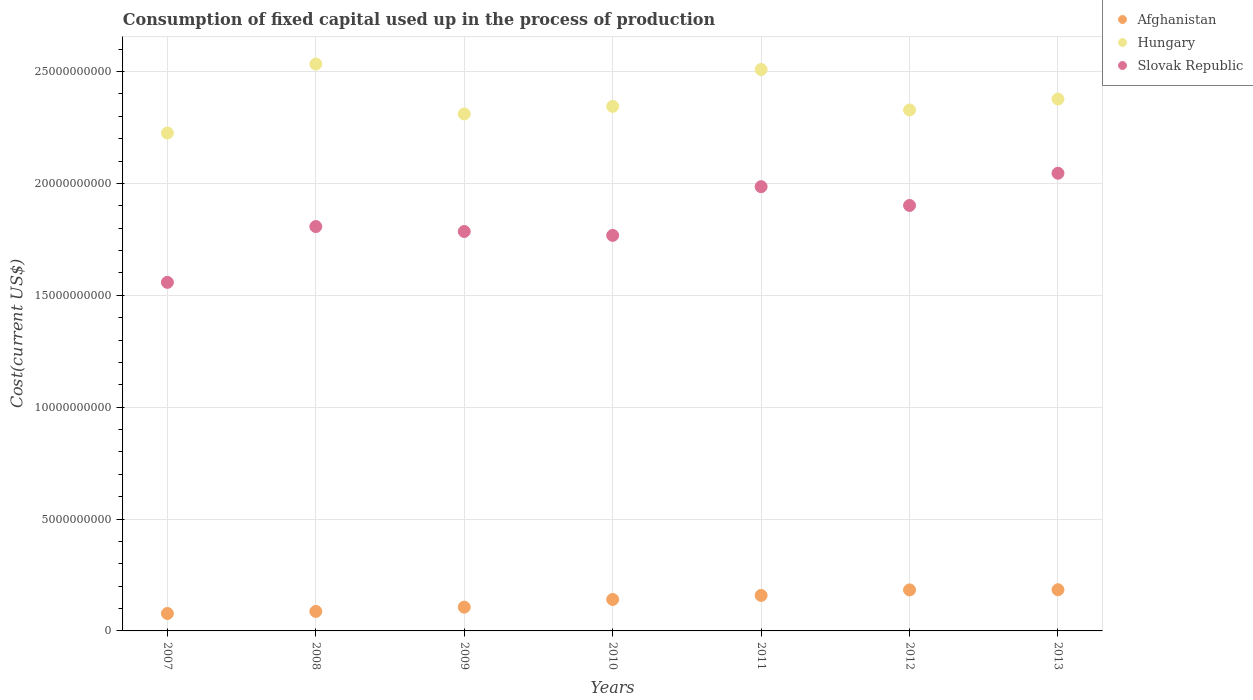How many different coloured dotlines are there?
Keep it short and to the point. 3. Is the number of dotlines equal to the number of legend labels?
Your response must be concise. Yes. What is the amount consumed in the process of production in Afghanistan in 2013?
Offer a very short reply. 1.84e+09. Across all years, what is the maximum amount consumed in the process of production in Hungary?
Offer a terse response. 2.53e+1. Across all years, what is the minimum amount consumed in the process of production in Afghanistan?
Your response must be concise. 7.79e+08. What is the total amount consumed in the process of production in Slovak Republic in the graph?
Keep it short and to the point. 1.29e+11. What is the difference between the amount consumed in the process of production in Afghanistan in 2008 and that in 2011?
Keep it short and to the point. -7.15e+08. What is the difference between the amount consumed in the process of production in Hungary in 2007 and the amount consumed in the process of production in Slovak Republic in 2010?
Provide a succinct answer. 4.58e+09. What is the average amount consumed in the process of production in Slovak Republic per year?
Your answer should be compact. 1.84e+1. In the year 2009, what is the difference between the amount consumed in the process of production in Slovak Republic and amount consumed in the process of production in Hungary?
Your answer should be very brief. -5.25e+09. In how many years, is the amount consumed in the process of production in Hungary greater than 2000000000 US$?
Ensure brevity in your answer.  7. What is the ratio of the amount consumed in the process of production in Slovak Republic in 2010 to that in 2012?
Provide a short and direct response. 0.93. Is the amount consumed in the process of production in Afghanistan in 2011 less than that in 2012?
Keep it short and to the point. Yes. What is the difference between the highest and the second highest amount consumed in the process of production in Slovak Republic?
Make the answer very short. 6.01e+08. What is the difference between the highest and the lowest amount consumed in the process of production in Slovak Republic?
Keep it short and to the point. 4.88e+09. Is the sum of the amount consumed in the process of production in Slovak Republic in 2011 and 2012 greater than the maximum amount consumed in the process of production in Hungary across all years?
Provide a succinct answer. Yes. Does the amount consumed in the process of production in Hungary monotonically increase over the years?
Keep it short and to the point. No. Is the amount consumed in the process of production in Afghanistan strictly greater than the amount consumed in the process of production in Slovak Republic over the years?
Ensure brevity in your answer.  No. Is the amount consumed in the process of production in Afghanistan strictly less than the amount consumed in the process of production in Slovak Republic over the years?
Offer a very short reply. Yes. How many dotlines are there?
Your answer should be compact. 3. How many years are there in the graph?
Offer a terse response. 7. What is the difference between two consecutive major ticks on the Y-axis?
Ensure brevity in your answer.  5.00e+09. Are the values on the major ticks of Y-axis written in scientific E-notation?
Offer a terse response. No. Does the graph contain any zero values?
Your answer should be very brief. No. Does the graph contain grids?
Your answer should be very brief. Yes. Where does the legend appear in the graph?
Keep it short and to the point. Top right. How many legend labels are there?
Provide a short and direct response. 3. How are the legend labels stacked?
Make the answer very short. Vertical. What is the title of the graph?
Make the answer very short. Consumption of fixed capital used up in the process of production. Does "Angola" appear as one of the legend labels in the graph?
Give a very brief answer. No. What is the label or title of the Y-axis?
Give a very brief answer. Cost(current US$). What is the Cost(current US$) of Afghanistan in 2007?
Provide a short and direct response. 7.79e+08. What is the Cost(current US$) of Hungary in 2007?
Offer a very short reply. 2.23e+1. What is the Cost(current US$) of Slovak Republic in 2007?
Offer a very short reply. 1.56e+1. What is the Cost(current US$) in Afghanistan in 2008?
Offer a very short reply. 8.72e+08. What is the Cost(current US$) in Hungary in 2008?
Make the answer very short. 2.53e+1. What is the Cost(current US$) in Slovak Republic in 2008?
Your answer should be compact. 1.81e+1. What is the Cost(current US$) of Afghanistan in 2009?
Keep it short and to the point. 1.06e+09. What is the Cost(current US$) of Hungary in 2009?
Your response must be concise. 2.31e+1. What is the Cost(current US$) in Slovak Republic in 2009?
Your answer should be very brief. 1.79e+1. What is the Cost(current US$) in Afghanistan in 2010?
Offer a terse response. 1.41e+09. What is the Cost(current US$) of Hungary in 2010?
Ensure brevity in your answer.  2.34e+1. What is the Cost(current US$) of Slovak Republic in 2010?
Ensure brevity in your answer.  1.77e+1. What is the Cost(current US$) of Afghanistan in 2011?
Offer a very short reply. 1.59e+09. What is the Cost(current US$) in Hungary in 2011?
Ensure brevity in your answer.  2.51e+1. What is the Cost(current US$) of Slovak Republic in 2011?
Give a very brief answer. 1.99e+1. What is the Cost(current US$) in Afghanistan in 2012?
Ensure brevity in your answer.  1.83e+09. What is the Cost(current US$) of Hungary in 2012?
Make the answer very short. 2.33e+1. What is the Cost(current US$) in Slovak Republic in 2012?
Make the answer very short. 1.90e+1. What is the Cost(current US$) of Afghanistan in 2013?
Offer a very short reply. 1.84e+09. What is the Cost(current US$) of Hungary in 2013?
Offer a very short reply. 2.38e+1. What is the Cost(current US$) in Slovak Republic in 2013?
Give a very brief answer. 2.05e+1. Across all years, what is the maximum Cost(current US$) of Afghanistan?
Keep it short and to the point. 1.84e+09. Across all years, what is the maximum Cost(current US$) in Hungary?
Provide a succinct answer. 2.53e+1. Across all years, what is the maximum Cost(current US$) in Slovak Republic?
Your answer should be very brief. 2.05e+1. Across all years, what is the minimum Cost(current US$) in Afghanistan?
Your response must be concise. 7.79e+08. Across all years, what is the minimum Cost(current US$) of Hungary?
Your answer should be compact. 2.23e+1. Across all years, what is the minimum Cost(current US$) in Slovak Republic?
Your response must be concise. 1.56e+1. What is the total Cost(current US$) in Afghanistan in the graph?
Give a very brief answer. 9.38e+09. What is the total Cost(current US$) of Hungary in the graph?
Provide a short and direct response. 1.66e+11. What is the total Cost(current US$) of Slovak Republic in the graph?
Give a very brief answer. 1.29e+11. What is the difference between the Cost(current US$) in Afghanistan in 2007 and that in 2008?
Provide a short and direct response. -9.27e+07. What is the difference between the Cost(current US$) in Hungary in 2007 and that in 2008?
Your response must be concise. -3.08e+09. What is the difference between the Cost(current US$) in Slovak Republic in 2007 and that in 2008?
Provide a succinct answer. -2.49e+09. What is the difference between the Cost(current US$) of Afghanistan in 2007 and that in 2009?
Your answer should be very brief. -2.84e+08. What is the difference between the Cost(current US$) of Hungary in 2007 and that in 2009?
Offer a terse response. -8.51e+08. What is the difference between the Cost(current US$) in Slovak Republic in 2007 and that in 2009?
Provide a succinct answer. -2.27e+09. What is the difference between the Cost(current US$) of Afghanistan in 2007 and that in 2010?
Offer a terse response. -6.28e+08. What is the difference between the Cost(current US$) in Hungary in 2007 and that in 2010?
Your answer should be very brief. -1.19e+09. What is the difference between the Cost(current US$) in Slovak Republic in 2007 and that in 2010?
Provide a succinct answer. -2.10e+09. What is the difference between the Cost(current US$) of Afghanistan in 2007 and that in 2011?
Make the answer very short. -8.08e+08. What is the difference between the Cost(current US$) of Hungary in 2007 and that in 2011?
Your answer should be very brief. -2.84e+09. What is the difference between the Cost(current US$) of Slovak Republic in 2007 and that in 2011?
Your answer should be very brief. -4.28e+09. What is the difference between the Cost(current US$) of Afghanistan in 2007 and that in 2012?
Your response must be concise. -1.05e+09. What is the difference between the Cost(current US$) of Hungary in 2007 and that in 2012?
Give a very brief answer. -1.03e+09. What is the difference between the Cost(current US$) of Slovak Republic in 2007 and that in 2012?
Provide a short and direct response. -3.44e+09. What is the difference between the Cost(current US$) in Afghanistan in 2007 and that in 2013?
Offer a very short reply. -1.06e+09. What is the difference between the Cost(current US$) in Hungary in 2007 and that in 2013?
Provide a succinct answer. -1.52e+09. What is the difference between the Cost(current US$) of Slovak Republic in 2007 and that in 2013?
Ensure brevity in your answer.  -4.88e+09. What is the difference between the Cost(current US$) in Afghanistan in 2008 and that in 2009?
Make the answer very short. -1.91e+08. What is the difference between the Cost(current US$) of Hungary in 2008 and that in 2009?
Give a very brief answer. 2.23e+09. What is the difference between the Cost(current US$) of Slovak Republic in 2008 and that in 2009?
Ensure brevity in your answer.  2.20e+08. What is the difference between the Cost(current US$) of Afghanistan in 2008 and that in 2010?
Give a very brief answer. -5.35e+08. What is the difference between the Cost(current US$) of Hungary in 2008 and that in 2010?
Keep it short and to the point. 1.89e+09. What is the difference between the Cost(current US$) in Slovak Republic in 2008 and that in 2010?
Your answer should be very brief. 3.95e+08. What is the difference between the Cost(current US$) in Afghanistan in 2008 and that in 2011?
Provide a short and direct response. -7.15e+08. What is the difference between the Cost(current US$) of Hungary in 2008 and that in 2011?
Your response must be concise. 2.45e+08. What is the difference between the Cost(current US$) of Slovak Republic in 2008 and that in 2011?
Ensure brevity in your answer.  -1.78e+09. What is the difference between the Cost(current US$) in Afghanistan in 2008 and that in 2012?
Give a very brief answer. -9.61e+08. What is the difference between the Cost(current US$) of Hungary in 2008 and that in 2012?
Provide a short and direct response. 2.05e+09. What is the difference between the Cost(current US$) in Slovak Republic in 2008 and that in 2012?
Your answer should be very brief. -9.43e+08. What is the difference between the Cost(current US$) in Afghanistan in 2008 and that in 2013?
Offer a very short reply. -9.69e+08. What is the difference between the Cost(current US$) in Hungary in 2008 and that in 2013?
Offer a terse response. 1.56e+09. What is the difference between the Cost(current US$) of Slovak Republic in 2008 and that in 2013?
Provide a succinct answer. -2.38e+09. What is the difference between the Cost(current US$) in Afghanistan in 2009 and that in 2010?
Provide a succinct answer. -3.43e+08. What is the difference between the Cost(current US$) of Hungary in 2009 and that in 2010?
Offer a very short reply. -3.38e+08. What is the difference between the Cost(current US$) of Slovak Republic in 2009 and that in 2010?
Provide a short and direct response. 1.75e+08. What is the difference between the Cost(current US$) of Afghanistan in 2009 and that in 2011?
Give a very brief answer. -5.24e+08. What is the difference between the Cost(current US$) of Hungary in 2009 and that in 2011?
Make the answer very short. -1.99e+09. What is the difference between the Cost(current US$) in Slovak Republic in 2009 and that in 2011?
Make the answer very short. -2.00e+09. What is the difference between the Cost(current US$) in Afghanistan in 2009 and that in 2012?
Your answer should be compact. -7.70e+08. What is the difference between the Cost(current US$) in Hungary in 2009 and that in 2012?
Ensure brevity in your answer.  -1.78e+08. What is the difference between the Cost(current US$) of Slovak Republic in 2009 and that in 2012?
Offer a very short reply. -1.16e+09. What is the difference between the Cost(current US$) of Afghanistan in 2009 and that in 2013?
Your response must be concise. -7.78e+08. What is the difference between the Cost(current US$) in Hungary in 2009 and that in 2013?
Your answer should be very brief. -6.66e+08. What is the difference between the Cost(current US$) of Slovak Republic in 2009 and that in 2013?
Ensure brevity in your answer.  -2.60e+09. What is the difference between the Cost(current US$) in Afghanistan in 2010 and that in 2011?
Offer a terse response. -1.80e+08. What is the difference between the Cost(current US$) of Hungary in 2010 and that in 2011?
Provide a succinct answer. -1.65e+09. What is the difference between the Cost(current US$) of Slovak Republic in 2010 and that in 2011?
Make the answer very short. -2.18e+09. What is the difference between the Cost(current US$) in Afghanistan in 2010 and that in 2012?
Ensure brevity in your answer.  -4.27e+08. What is the difference between the Cost(current US$) of Hungary in 2010 and that in 2012?
Keep it short and to the point. 1.59e+08. What is the difference between the Cost(current US$) in Slovak Republic in 2010 and that in 2012?
Your answer should be compact. -1.34e+09. What is the difference between the Cost(current US$) of Afghanistan in 2010 and that in 2013?
Make the answer very short. -4.34e+08. What is the difference between the Cost(current US$) of Hungary in 2010 and that in 2013?
Your answer should be very brief. -3.28e+08. What is the difference between the Cost(current US$) of Slovak Republic in 2010 and that in 2013?
Offer a terse response. -2.78e+09. What is the difference between the Cost(current US$) in Afghanistan in 2011 and that in 2012?
Offer a very short reply. -2.46e+08. What is the difference between the Cost(current US$) of Hungary in 2011 and that in 2012?
Give a very brief answer. 1.81e+09. What is the difference between the Cost(current US$) of Slovak Republic in 2011 and that in 2012?
Give a very brief answer. 8.39e+08. What is the difference between the Cost(current US$) of Afghanistan in 2011 and that in 2013?
Provide a short and direct response. -2.54e+08. What is the difference between the Cost(current US$) of Hungary in 2011 and that in 2013?
Your answer should be very brief. 1.32e+09. What is the difference between the Cost(current US$) in Slovak Republic in 2011 and that in 2013?
Provide a short and direct response. -6.01e+08. What is the difference between the Cost(current US$) of Afghanistan in 2012 and that in 2013?
Provide a short and direct response. -7.81e+06. What is the difference between the Cost(current US$) in Hungary in 2012 and that in 2013?
Offer a terse response. -4.88e+08. What is the difference between the Cost(current US$) of Slovak Republic in 2012 and that in 2013?
Your answer should be very brief. -1.44e+09. What is the difference between the Cost(current US$) of Afghanistan in 2007 and the Cost(current US$) of Hungary in 2008?
Your answer should be very brief. -2.46e+1. What is the difference between the Cost(current US$) of Afghanistan in 2007 and the Cost(current US$) of Slovak Republic in 2008?
Offer a terse response. -1.73e+1. What is the difference between the Cost(current US$) of Hungary in 2007 and the Cost(current US$) of Slovak Republic in 2008?
Your answer should be very brief. 4.18e+09. What is the difference between the Cost(current US$) in Afghanistan in 2007 and the Cost(current US$) in Hungary in 2009?
Provide a short and direct response. -2.23e+1. What is the difference between the Cost(current US$) of Afghanistan in 2007 and the Cost(current US$) of Slovak Republic in 2009?
Your response must be concise. -1.71e+1. What is the difference between the Cost(current US$) of Hungary in 2007 and the Cost(current US$) of Slovak Republic in 2009?
Your answer should be compact. 4.40e+09. What is the difference between the Cost(current US$) of Afghanistan in 2007 and the Cost(current US$) of Hungary in 2010?
Make the answer very short. -2.27e+1. What is the difference between the Cost(current US$) in Afghanistan in 2007 and the Cost(current US$) in Slovak Republic in 2010?
Your response must be concise. -1.69e+1. What is the difference between the Cost(current US$) of Hungary in 2007 and the Cost(current US$) of Slovak Republic in 2010?
Provide a short and direct response. 4.58e+09. What is the difference between the Cost(current US$) in Afghanistan in 2007 and the Cost(current US$) in Hungary in 2011?
Ensure brevity in your answer.  -2.43e+1. What is the difference between the Cost(current US$) in Afghanistan in 2007 and the Cost(current US$) in Slovak Republic in 2011?
Provide a succinct answer. -1.91e+1. What is the difference between the Cost(current US$) of Hungary in 2007 and the Cost(current US$) of Slovak Republic in 2011?
Your answer should be very brief. 2.40e+09. What is the difference between the Cost(current US$) of Afghanistan in 2007 and the Cost(current US$) of Hungary in 2012?
Ensure brevity in your answer.  -2.25e+1. What is the difference between the Cost(current US$) in Afghanistan in 2007 and the Cost(current US$) in Slovak Republic in 2012?
Your answer should be compact. -1.82e+1. What is the difference between the Cost(current US$) of Hungary in 2007 and the Cost(current US$) of Slovak Republic in 2012?
Offer a terse response. 3.24e+09. What is the difference between the Cost(current US$) of Afghanistan in 2007 and the Cost(current US$) of Hungary in 2013?
Keep it short and to the point. -2.30e+1. What is the difference between the Cost(current US$) of Afghanistan in 2007 and the Cost(current US$) of Slovak Republic in 2013?
Ensure brevity in your answer.  -1.97e+1. What is the difference between the Cost(current US$) in Hungary in 2007 and the Cost(current US$) in Slovak Republic in 2013?
Give a very brief answer. 1.80e+09. What is the difference between the Cost(current US$) in Afghanistan in 2008 and the Cost(current US$) in Hungary in 2009?
Your answer should be compact. -2.22e+1. What is the difference between the Cost(current US$) in Afghanistan in 2008 and the Cost(current US$) in Slovak Republic in 2009?
Make the answer very short. -1.70e+1. What is the difference between the Cost(current US$) in Hungary in 2008 and the Cost(current US$) in Slovak Republic in 2009?
Offer a terse response. 7.48e+09. What is the difference between the Cost(current US$) of Afghanistan in 2008 and the Cost(current US$) of Hungary in 2010?
Ensure brevity in your answer.  -2.26e+1. What is the difference between the Cost(current US$) in Afghanistan in 2008 and the Cost(current US$) in Slovak Republic in 2010?
Your response must be concise. -1.68e+1. What is the difference between the Cost(current US$) of Hungary in 2008 and the Cost(current US$) of Slovak Republic in 2010?
Your response must be concise. 7.66e+09. What is the difference between the Cost(current US$) in Afghanistan in 2008 and the Cost(current US$) in Hungary in 2011?
Provide a succinct answer. -2.42e+1. What is the difference between the Cost(current US$) of Afghanistan in 2008 and the Cost(current US$) of Slovak Republic in 2011?
Give a very brief answer. -1.90e+1. What is the difference between the Cost(current US$) of Hungary in 2008 and the Cost(current US$) of Slovak Republic in 2011?
Your answer should be very brief. 5.48e+09. What is the difference between the Cost(current US$) in Afghanistan in 2008 and the Cost(current US$) in Hungary in 2012?
Your answer should be compact. -2.24e+1. What is the difference between the Cost(current US$) of Afghanistan in 2008 and the Cost(current US$) of Slovak Republic in 2012?
Ensure brevity in your answer.  -1.81e+1. What is the difference between the Cost(current US$) of Hungary in 2008 and the Cost(current US$) of Slovak Republic in 2012?
Your answer should be very brief. 6.32e+09. What is the difference between the Cost(current US$) in Afghanistan in 2008 and the Cost(current US$) in Hungary in 2013?
Offer a very short reply. -2.29e+1. What is the difference between the Cost(current US$) of Afghanistan in 2008 and the Cost(current US$) of Slovak Republic in 2013?
Offer a terse response. -1.96e+1. What is the difference between the Cost(current US$) of Hungary in 2008 and the Cost(current US$) of Slovak Republic in 2013?
Your answer should be very brief. 4.88e+09. What is the difference between the Cost(current US$) of Afghanistan in 2009 and the Cost(current US$) of Hungary in 2010?
Offer a terse response. -2.24e+1. What is the difference between the Cost(current US$) of Afghanistan in 2009 and the Cost(current US$) of Slovak Republic in 2010?
Provide a succinct answer. -1.66e+1. What is the difference between the Cost(current US$) of Hungary in 2009 and the Cost(current US$) of Slovak Republic in 2010?
Offer a very short reply. 5.43e+09. What is the difference between the Cost(current US$) of Afghanistan in 2009 and the Cost(current US$) of Hungary in 2011?
Make the answer very short. -2.40e+1. What is the difference between the Cost(current US$) in Afghanistan in 2009 and the Cost(current US$) in Slovak Republic in 2011?
Provide a succinct answer. -1.88e+1. What is the difference between the Cost(current US$) in Hungary in 2009 and the Cost(current US$) in Slovak Republic in 2011?
Provide a short and direct response. 3.25e+09. What is the difference between the Cost(current US$) in Afghanistan in 2009 and the Cost(current US$) in Hungary in 2012?
Give a very brief answer. -2.22e+1. What is the difference between the Cost(current US$) of Afghanistan in 2009 and the Cost(current US$) of Slovak Republic in 2012?
Your response must be concise. -1.80e+1. What is the difference between the Cost(current US$) of Hungary in 2009 and the Cost(current US$) of Slovak Republic in 2012?
Offer a terse response. 4.09e+09. What is the difference between the Cost(current US$) in Afghanistan in 2009 and the Cost(current US$) in Hungary in 2013?
Give a very brief answer. -2.27e+1. What is the difference between the Cost(current US$) in Afghanistan in 2009 and the Cost(current US$) in Slovak Republic in 2013?
Your answer should be very brief. -1.94e+1. What is the difference between the Cost(current US$) in Hungary in 2009 and the Cost(current US$) in Slovak Republic in 2013?
Your response must be concise. 2.65e+09. What is the difference between the Cost(current US$) of Afghanistan in 2010 and the Cost(current US$) of Hungary in 2011?
Your response must be concise. -2.37e+1. What is the difference between the Cost(current US$) in Afghanistan in 2010 and the Cost(current US$) in Slovak Republic in 2011?
Provide a succinct answer. -1.84e+1. What is the difference between the Cost(current US$) of Hungary in 2010 and the Cost(current US$) of Slovak Republic in 2011?
Offer a very short reply. 3.59e+09. What is the difference between the Cost(current US$) of Afghanistan in 2010 and the Cost(current US$) of Hungary in 2012?
Give a very brief answer. -2.19e+1. What is the difference between the Cost(current US$) of Afghanistan in 2010 and the Cost(current US$) of Slovak Republic in 2012?
Provide a succinct answer. -1.76e+1. What is the difference between the Cost(current US$) in Hungary in 2010 and the Cost(current US$) in Slovak Republic in 2012?
Offer a terse response. 4.43e+09. What is the difference between the Cost(current US$) in Afghanistan in 2010 and the Cost(current US$) in Hungary in 2013?
Your answer should be compact. -2.24e+1. What is the difference between the Cost(current US$) in Afghanistan in 2010 and the Cost(current US$) in Slovak Republic in 2013?
Provide a succinct answer. -1.91e+1. What is the difference between the Cost(current US$) in Hungary in 2010 and the Cost(current US$) in Slovak Republic in 2013?
Keep it short and to the point. 2.99e+09. What is the difference between the Cost(current US$) of Afghanistan in 2011 and the Cost(current US$) of Hungary in 2012?
Offer a very short reply. -2.17e+1. What is the difference between the Cost(current US$) in Afghanistan in 2011 and the Cost(current US$) in Slovak Republic in 2012?
Ensure brevity in your answer.  -1.74e+1. What is the difference between the Cost(current US$) in Hungary in 2011 and the Cost(current US$) in Slovak Republic in 2012?
Keep it short and to the point. 6.08e+09. What is the difference between the Cost(current US$) of Afghanistan in 2011 and the Cost(current US$) of Hungary in 2013?
Offer a terse response. -2.22e+1. What is the difference between the Cost(current US$) in Afghanistan in 2011 and the Cost(current US$) in Slovak Republic in 2013?
Provide a succinct answer. -1.89e+1. What is the difference between the Cost(current US$) in Hungary in 2011 and the Cost(current US$) in Slovak Republic in 2013?
Your answer should be compact. 4.64e+09. What is the difference between the Cost(current US$) of Afghanistan in 2012 and the Cost(current US$) of Hungary in 2013?
Ensure brevity in your answer.  -2.19e+1. What is the difference between the Cost(current US$) of Afghanistan in 2012 and the Cost(current US$) of Slovak Republic in 2013?
Offer a very short reply. -1.86e+1. What is the difference between the Cost(current US$) in Hungary in 2012 and the Cost(current US$) in Slovak Republic in 2013?
Offer a very short reply. 2.83e+09. What is the average Cost(current US$) of Afghanistan per year?
Your answer should be compact. 1.34e+09. What is the average Cost(current US$) in Hungary per year?
Keep it short and to the point. 2.38e+1. What is the average Cost(current US$) of Slovak Republic per year?
Ensure brevity in your answer.  1.84e+1. In the year 2007, what is the difference between the Cost(current US$) of Afghanistan and Cost(current US$) of Hungary?
Ensure brevity in your answer.  -2.15e+1. In the year 2007, what is the difference between the Cost(current US$) of Afghanistan and Cost(current US$) of Slovak Republic?
Provide a short and direct response. -1.48e+1. In the year 2007, what is the difference between the Cost(current US$) of Hungary and Cost(current US$) of Slovak Republic?
Your response must be concise. 6.68e+09. In the year 2008, what is the difference between the Cost(current US$) in Afghanistan and Cost(current US$) in Hungary?
Provide a short and direct response. -2.45e+1. In the year 2008, what is the difference between the Cost(current US$) of Afghanistan and Cost(current US$) of Slovak Republic?
Offer a terse response. -1.72e+1. In the year 2008, what is the difference between the Cost(current US$) in Hungary and Cost(current US$) in Slovak Republic?
Your answer should be very brief. 7.26e+09. In the year 2009, what is the difference between the Cost(current US$) of Afghanistan and Cost(current US$) of Hungary?
Give a very brief answer. -2.20e+1. In the year 2009, what is the difference between the Cost(current US$) in Afghanistan and Cost(current US$) in Slovak Republic?
Provide a succinct answer. -1.68e+1. In the year 2009, what is the difference between the Cost(current US$) in Hungary and Cost(current US$) in Slovak Republic?
Your answer should be very brief. 5.25e+09. In the year 2010, what is the difference between the Cost(current US$) of Afghanistan and Cost(current US$) of Hungary?
Keep it short and to the point. -2.20e+1. In the year 2010, what is the difference between the Cost(current US$) in Afghanistan and Cost(current US$) in Slovak Republic?
Your answer should be very brief. -1.63e+1. In the year 2010, what is the difference between the Cost(current US$) in Hungary and Cost(current US$) in Slovak Republic?
Provide a short and direct response. 5.77e+09. In the year 2011, what is the difference between the Cost(current US$) in Afghanistan and Cost(current US$) in Hungary?
Your answer should be compact. -2.35e+1. In the year 2011, what is the difference between the Cost(current US$) of Afghanistan and Cost(current US$) of Slovak Republic?
Your answer should be compact. -1.83e+1. In the year 2011, what is the difference between the Cost(current US$) in Hungary and Cost(current US$) in Slovak Republic?
Offer a very short reply. 5.24e+09. In the year 2012, what is the difference between the Cost(current US$) of Afghanistan and Cost(current US$) of Hungary?
Provide a succinct answer. -2.15e+1. In the year 2012, what is the difference between the Cost(current US$) of Afghanistan and Cost(current US$) of Slovak Republic?
Your answer should be compact. -1.72e+1. In the year 2012, what is the difference between the Cost(current US$) in Hungary and Cost(current US$) in Slovak Republic?
Make the answer very short. 4.27e+09. In the year 2013, what is the difference between the Cost(current US$) of Afghanistan and Cost(current US$) of Hungary?
Make the answer very short. -2.19e+1. In the year 2013, what is the difference between the Cost(current US$) of Afghanistan and Cost(current US$) of Slovak Republic?
Ensure brevity in your answer.  -1.86e+1. In the year 2013, what is the difference between the Cost(current US$) of Hungary and Cost(current US$) of Slovak Republic?
Your answer should be very brief. 3.32e+09. What is the ratio of the Cost(current US$) of Afghanistan in 2007 to that in 2008?
Provide a short and direct response. 0.89. What is the ratio of the Cost(current US$) of Hungary in 2007 to that in 2008?
Offer a very short reply. 0.88. What is the ratio of the Cost(current US$) of Slovak Republic in 2007 to that in 2008?
Your answer should be very brief. 0.86. What is the ratio of the Cost(current US$) in Afghanistan in 2007 to that in 2009?
Your answer should be very brief. 0.73. What is the ratio of the Cost(current US$) in Hungary in 2007 to that in 2009?
Keep it short and to the point. 0.96. What is the ratio of the Cost(current US$) in Slovak Republic in 2007 to that in 2009?
Your answer should be very brief. 0.87. What is the ratio of the Cost(current US$) in Afghanistan in 2007 to that in 2010?
Ensure brevity in your answer.  0.55. What is the ratio of the Cost(current US$) in Hungary in 2007 to that in 2010?
Your answer should be very brief. 0.95. What is the ratio of the Cost(current US$) in Slovak Republic in 2007 to that in 2010?
Provide a short and direct response. 0.88. What is the ratio of the Cost(current US$) in Afghanistan in 2007 to that in 2011?
Make the answer very short. 0.49. What is the ratio of the Cost(current US$) in Hungary in 2007 to that in 2011?
Your answer should be very brief. 0.89. What is the ratio of the Cost(current US$) in Slovak Republic in 2007 to that in 2011?
Make the answer very short. 0.78. What is the ratio of the Cost(current US$) of Afghanistan in 2007 to that in 2012?
Your answer should be very brief. 0.42. What is the ratio of the Cost(current US$) of Hungary in 2007 to that in 2012?
Ensure brevity in your answer.  0.96. What is the ratio of the Cost(current US$) in Slovak Republic in 2007 to that in 2012?
Ensure brevity in your answer.  0.82. What is the ratio of the Cost(current US$) of Afghanistan in 2007 to that in 2013?
Provide a succinct answer. 0.42. What is the ratio of the Cost(current US$) of Hungary in 2007 to that in 2013?
Your answer should be very brief. 0.94. What is the ratio of the Cost(current US$) in Slovak Republic in 2007 to that in 2013?
Ensure brevity in your answer.  0.76. What is the ratio of the Cost(current US$) of Afghanistan in 2008 to that in 2009?
Give a very brief answer. 0.82. What is the ratio of the Cost(current US$) of Hungary in 2008 to that in 2009?
Offer a very short reply. 1.1. What is the ratio of the Cost(current US$) in Slovak Republic in 2008 to that in 2009?
Offer a very short reply. 1.01. What is the ratio of the Cost(current US$) of Afghanistan in 2008 to that in 2010?
Provide a short and direct response. 0.62. What is the ratio of the Cost(current US$) in Hungary in 2008 to that in 2010?
Make the answer very short. 1.08. What is the ratio of the Cost(current US$) in Slovak Republic in 2008 to that in 2010?
Provide a succinct answer. 1.02. What is the ratio of the Cost(current US$) of Afghanistan in 2008 to that in 2011?
Your response must be concise. 0.55. What is the ratio of the Cost(current US$) of Hungary in 2008 to that in 2011?
Ensure brevity in your answer.  1.01. What is the ratio of the Cost(current US$) of Slovak Republic in 2008 to that in 2011?
Offer a very short reply. 0.91. What is the ratio of the Cost(current US$) of Afghanistan in 2008 to that in 2012?
Offer a terse response. 0.48. What is the ratio of the Cost(current US$) in Hungary in 2008 to that in 2012?
Your answer should be very brief. 1.09. What is the ratio of the Cost(current US$) in Slovak Republic in 2008 to that in 2012?
Make the answer very short. 0.95. What is the ratio of the Cost(current US$) of Afghanistan in 2008 to that in 2013?
Your answer should be compact. 0.47. What is the ratio of the Cost(current US$) of Hungary in 2008 to that in 2013?
Give a very brief answer. 1.07. What is the ratio of the Cost(current US$) of Slovak Republic in 2008 to that in 2013?
Keep it short and to the point. 0.88. What is the ratio of the Cost(current US$) of Afghanistan in 2009 to that in 2010?
Offer a very short reply. 0.76. What is the ratio of the Cost(current US$) of Hungary in 2009 to that in 2010?
Offer a very short reply. 0.99. What is the ratio of the Cost(current US$) of Slovak Republic in 2009 to that in 2010?
Ensure brevity in your answer.  1.01. What is the ratio of the Cost(current US$) in Afghanistan in 2009 to that in 2011?
Your response must be concise. 0.67. What is the ratio of the Cost(current US$) of Hungary in 2009 to that in 2011?
Provide a succinct answer. 0.92. What is the ratio of the Cost(current US$) of Slovak Republic in 2009 to that in 2011?
Ensure brevity in your answer.  0.9. What is the ratio of the Cost(current US$) of Afghanistan in 2009 to that in 2012?
Your response must be concise. 0.58. What is the ratio of the Cost(current US$) of Hungary in 2009 to that in 2012?
Make the answer very short. 0.99. What is the ratio of the Cost(current US$) of Slovak Republic in 2009 to that in 2012?
Your answer should be compact. 0.94. What is the ratio of the Cost(current US$) of Afghanistan in 2009 to that in 2013?
Offer a very short reply. 0.58. What is the ratio of the Cost(current US$) of Slovak Republic in 2009 to that in 2013?
Your answer should be compact. 0.87. What is the ratio of the Cost(current US$) in Afghanistan in 2010 to that in 2011?
Offer a terse response. 0.89. What is the ratio of the Cost(current US$) of Hungary in 2010 to that in 2011?
Make the answer very short. 0.93. What is the ratio of the Cost(current US$) in Slovak Republic in 2010 to that in 2011?
Offer a terse response. 0.89. What is the ratio of the Cost(current US$) of Afghanistan in 2010 to that in 2012?
Your answer should be compact. 0.77. What is the ratio of the Cost(current US$) of Hungary in 2010 to that in 2012?
Provide a short and direct response. 1.01. What is the ratio of the Cost(current US$) of Slovak Republic in 2010 to that in 2012?
Your response must be concise. 0.93. What is the ratio of the Cost(current US$) of Afghanistan in 2010 to that in 2013?
Your answer should be very brief. 0.76. What is the ratio of the Cost(current US$) in Hungary in 2010 to that in 2013?
Your response must be concise. 0.99. What is the ratio of the Cost(current US$) in Slovak Republic in 2010 to that in 2013?
Make the answer very short. 0.86. What is the ratio of the Cost(current US$) of Afghanistan in 2011 to that in 2012?
Offer a terse response. 0.87. What is the ratio of the Cost(current US$) of Hungary in 2011 to that in 2012?
Provide a succinct answer. 1.08. What is the ratio of the Cost(current US$) in Slovak Republic in 2011 to that in 2012?
Ensure brevity in your answer.  1.04. What is the ratio of the Cost(current US$) in Afghanistan in 2011 to that in 2013?
Provide a succinct answer. 0.86. What is the ratio of the Cost(current US$) of Hungary in 2011 to that in 2013?
Your answer should be compact. 1.06. What is the ratio of the Cost(current US$) in Slovak Republic in 2011 to that in 2013?
Your response must be concise. 0.97. What is the ratio of the Cost(current US$) of Hungary in 2012 to that in 2013?
Provide a succinct answer. 0.98. What is the ratio of the Cost(current US$) in Slovak Republic in 2012 to that in 2013?
Give a very brief answer. 0.93. What is the difference between the highest and the second highest Cost(current US$) of Afghanistan?
Your response must be concise. 7.81e+06. What is the difference between the highest and the second highest Cost(current US$) in Hungary?
Offer a terse response. 2.45e+08. What is the difference between the highest and the second highest Cost(current US$) in Slovak Republic?
Give a very brief answer. 6.01e+08. What is the difference between the highest and the lowest Cost(current US$) in Afghanistan?
Your answer should be compact. 1.06e+09. What is the difference between the highest and the lowest Cost(current US$) of Hungary?
Your answer should be very brief. 3.08e+09. What is the difference between the highest and the lowest Cost(current US$) of Slovak Republic?
Ensure brevity in your answer.  4.88e+09. 